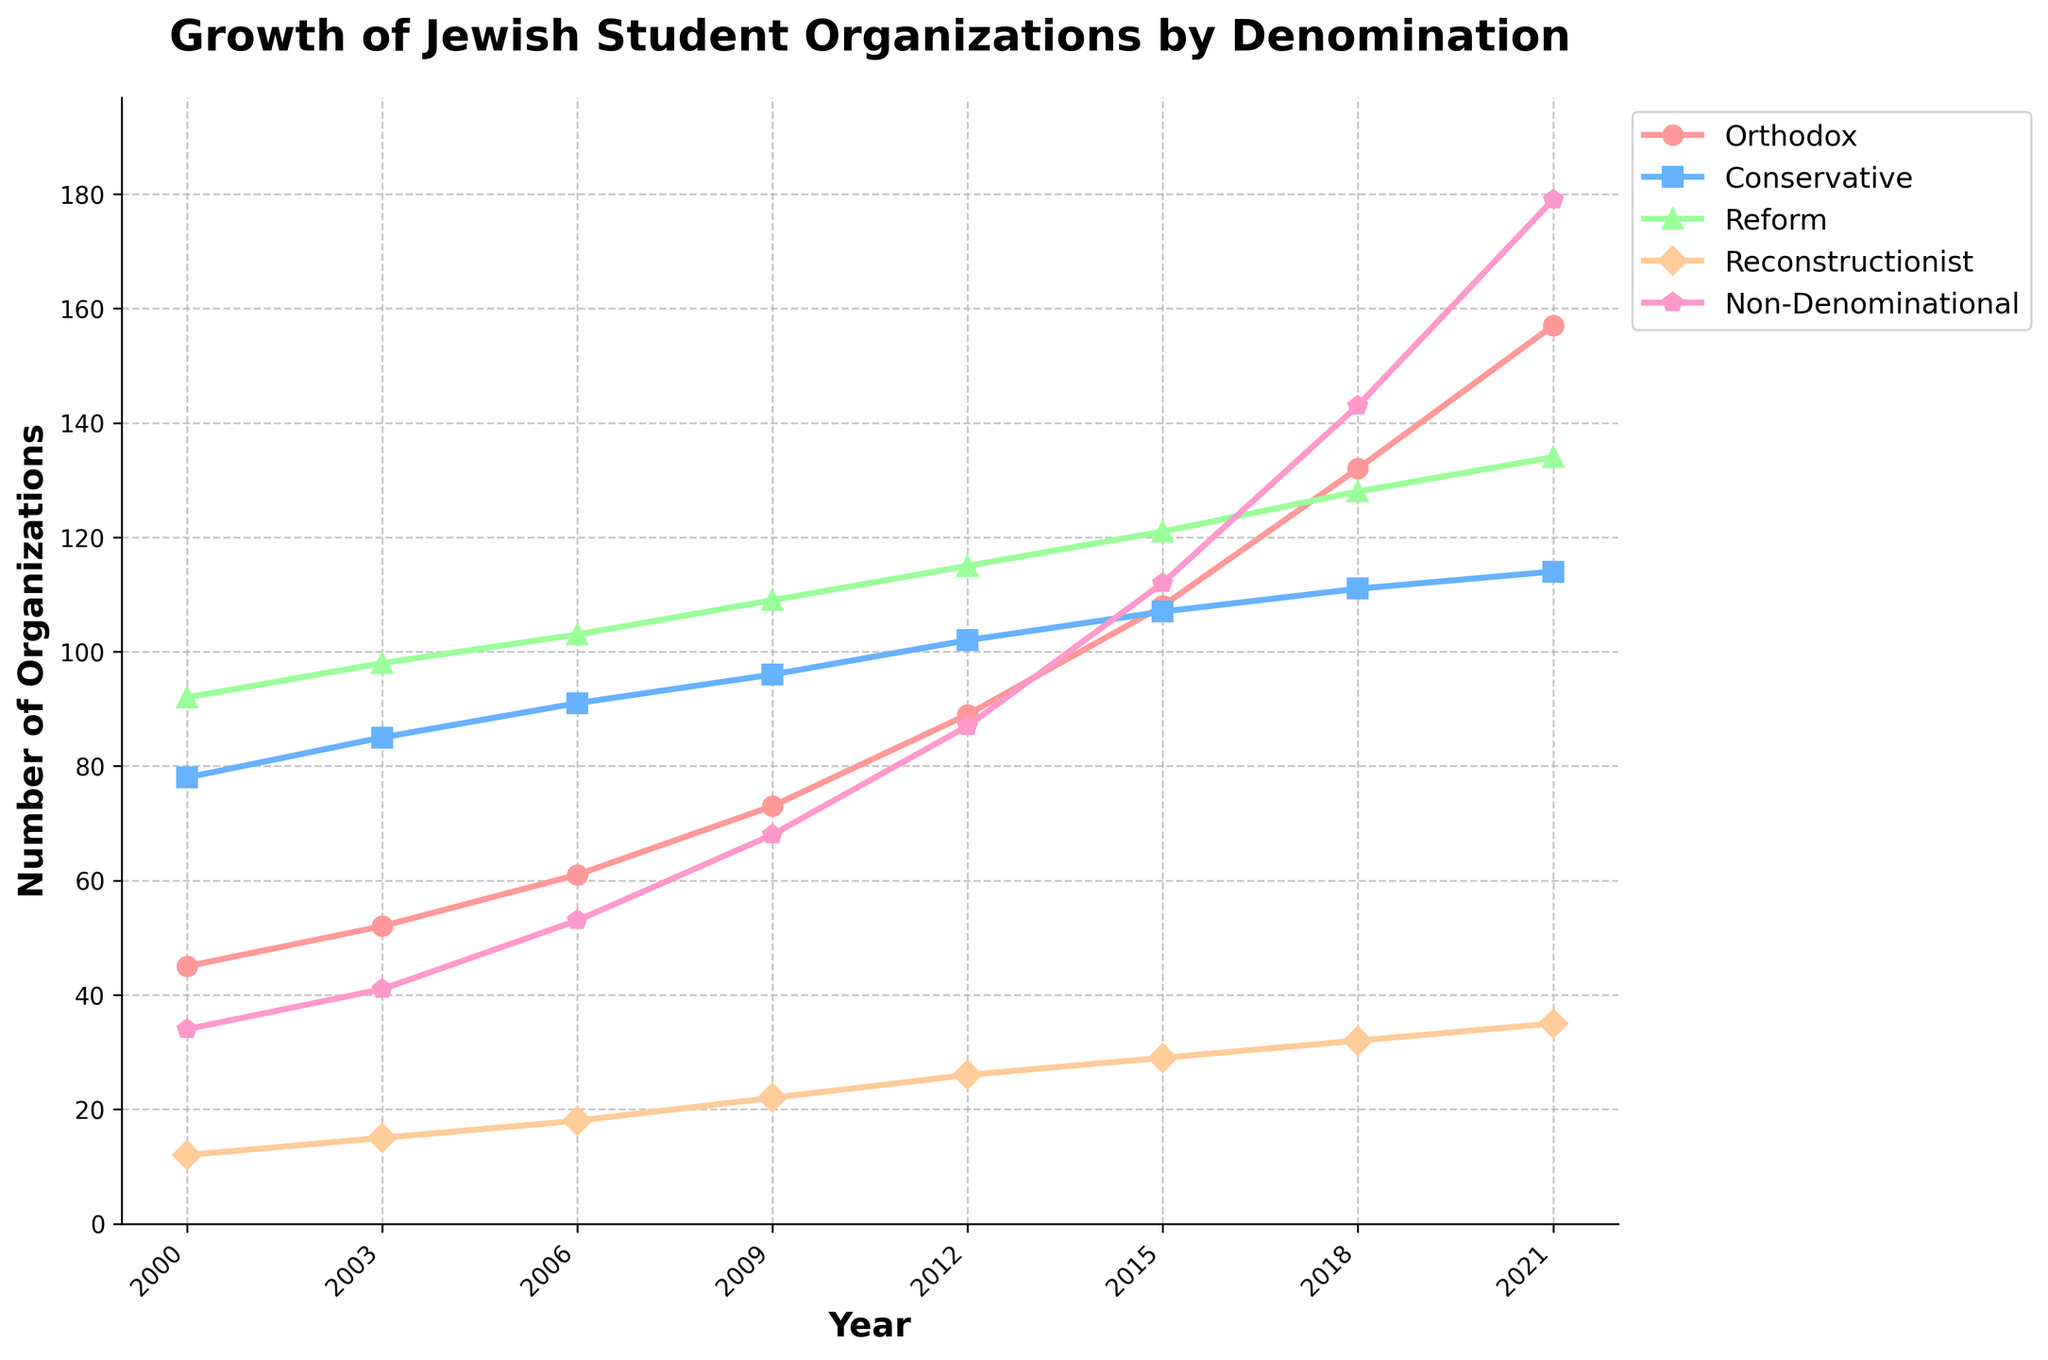What was the number of Orthodox Jewish student organizations in 2006? The height of the point for Orthodox in 2006 on the plot can be read directly.
Answer: 61 Which denomination had the most significant increase in the number of student organizations from 2000 to 2021? Look at each line on the plot from 2000 to 2021 and determine which has the steepest upward trend.
Answer: Non-Denominational Between which years did the Conservative Jewish student organizations experience the smallest growth? Compare the slope of the Conservative line segment between each pair of consecutive years to find the flattest one.
Answer: 2018 to 2021 How many more Reform Jewish student organizations were there in 2021 compared to 2000? Subtract the number of Reform organizations in 2000 from the number in 2021 using the heights of the respective points on the plot.
Answer: 42 Which denomination had the least dramatic changes in the number of organizations over time? The flattest line on the plot indicates the denomination with the least change over the years.
Answer: Reconstructionist What’s the sum of all Jewish student organizations in 2018? Add up the number of organizations for each denomination in 2018: 132 (Orthodox) + 111 (Conservative) + 128 (Reform) + 32 (Reconstructionist) + 143 (Non-Denominational).
Answer: 546 Which denomination surpassed the 100-organization mark first, and in what year? Look for the point at which each denomination's line crosses the 100 mark and identify the first occurrence.
Answer: Reform in 2006 By how much did the number of Non-Denominational organizations grow from 2009 to 2021? Subtract the number of Non-Denominational organizations in 2009 from the number in 2021: 179 - 68.
Answer: 111 Was the growth rate of Orthodox organizations between 2000 and 2003 greater than between 2018 and 2021? Calculate the rate of growth for both periods (rate = (final - initial) / number of years) and compare them: (52 - 45) / 3 and (157 - 132) / 3.
Answer: No In 2015, which denomination had a higher number of organizations: Conservative or Reform? Compare the heights of the points for Conservative and Reform in 2015.
Answer: Reform 